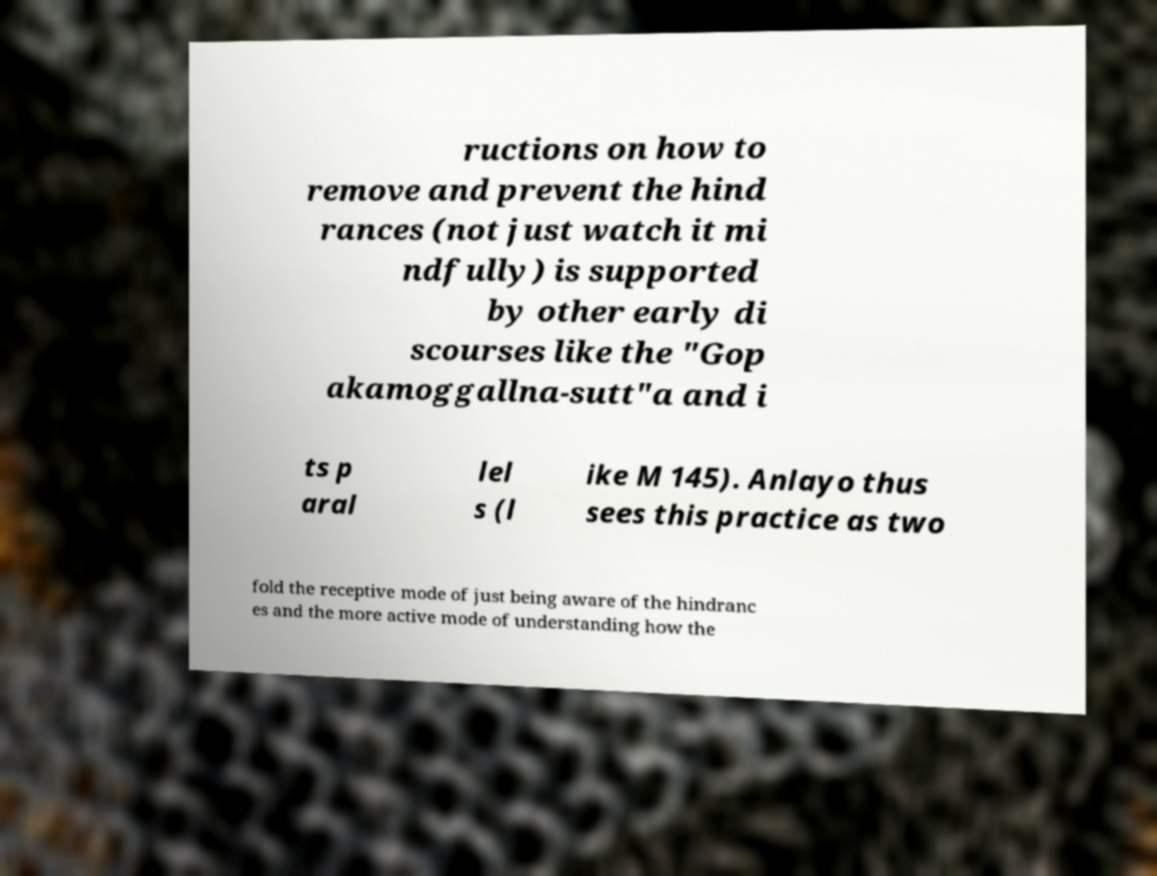Could you extract and type out the text from this image? ructions on how to remove and prevent the hind rances (not just watch it mi ndfully) is supported by other early di scourses like the "Gop akamoggallna-sutt"a and i ts p aral lel s (l ike M 145). Anlayo thus sees this practice as two fold the receptive mode of just being aware of the hindranc es and the more active mode of understanding how the 